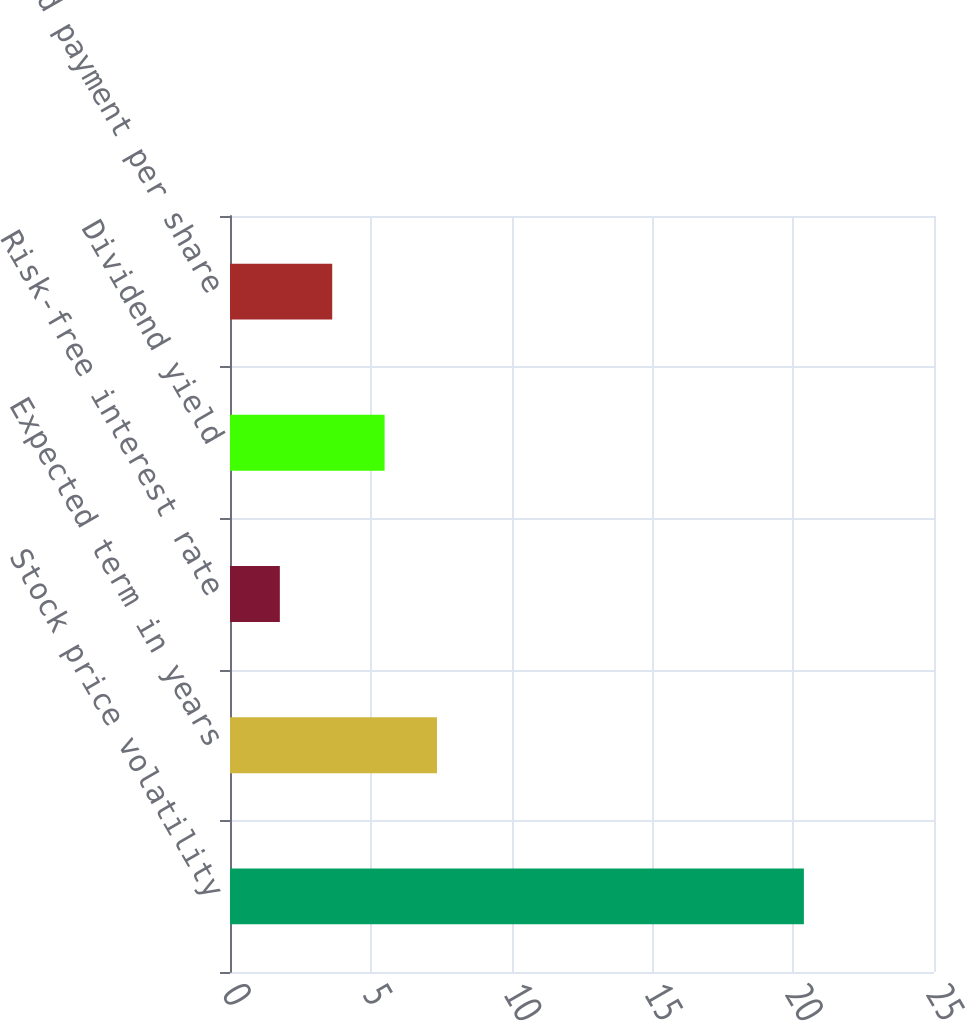Convert chart to OTSL. <chart><loc_0><loc_0><loc_500><loc_500><bar_chart><fcel>Stock price volatility<fcel>Expected term in years<fcel>Risk-free interest rate<fcel>Dividend yield<fcel>Dividend payment per share<nl><fcel>20.38<fcel>7.35<fcel>1.77<fcel>5.49<fcel>3.63<nl></chart> 